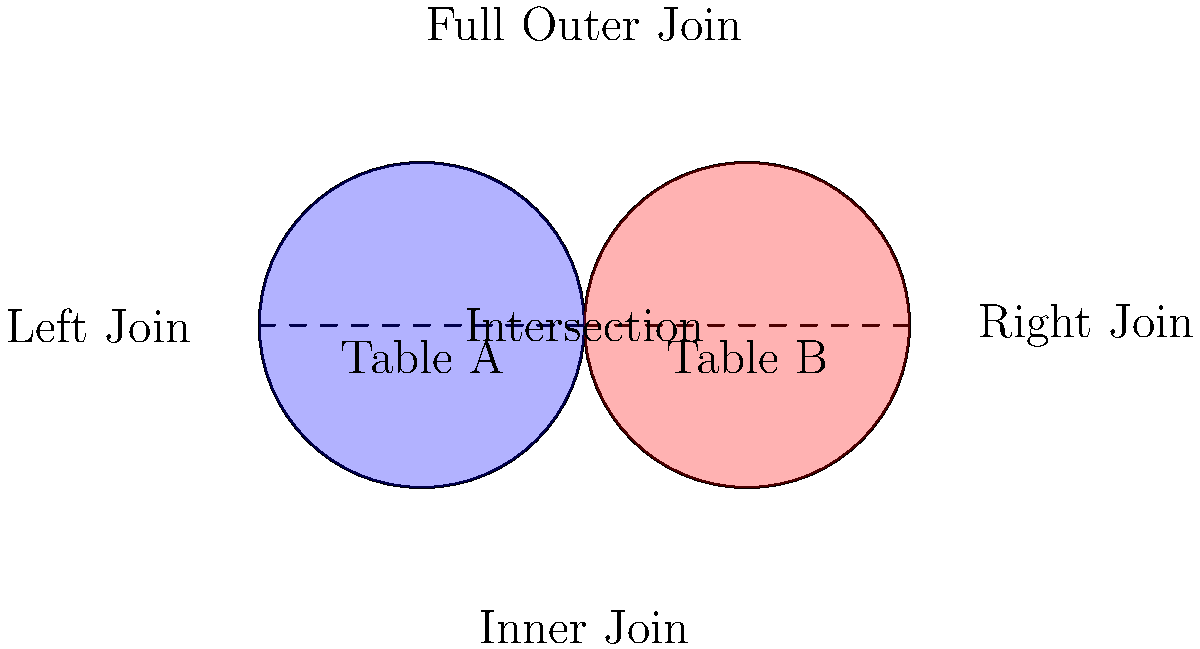Based on the diagram, which SQL join type would return all records from Table A, regardless of whether there are matching records in Table B? To answer this question, let's analyze the different types of SQL joins illustrated in the diagram:

1. Inner Join: This is represented by the intersection of the two circles. It returns only the matching records from both tables.

2. Left Join: This is indicated on the left side of the diagram. It returns all records from the left table (Table A) and the matching records from the right table (Table B).

3. Right Join: This is shown on the right side of the diagram. It returns all records from the right table (Table B) and the matching records from the left table (Table A).

4. Full Outer Join: This is represented by the entire area covered by both circles. It returns all records from both tables, with NULL values for non-matching records.

The question asks for the join type that returns all records from Table A, regardless of whether there are matching records in Table B. This description matches the Left Join, as it includes all records from the left table (Table A) and only the matching records from the right table (Table B).
Answer: Left Join 